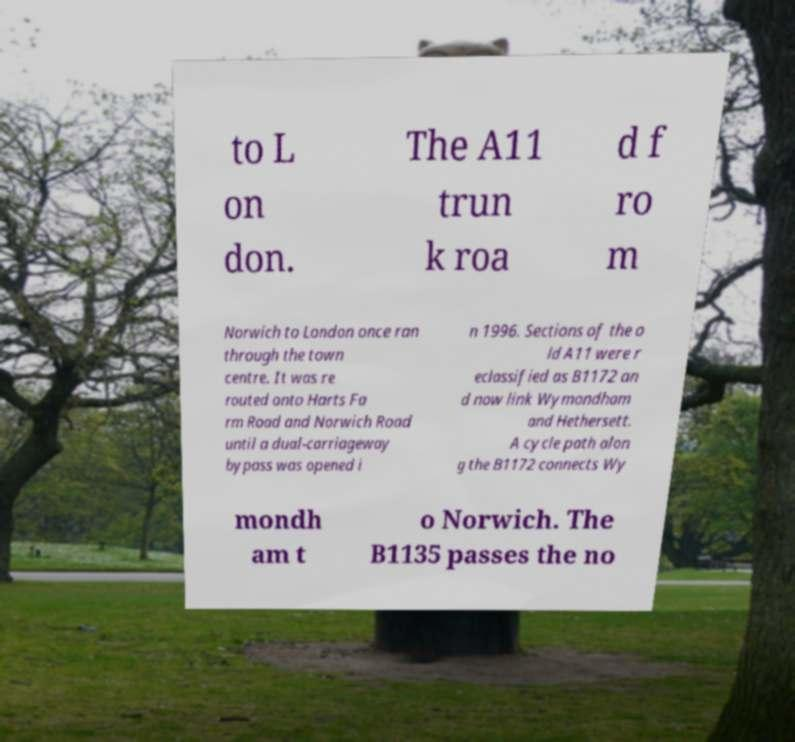Can you read and provide the text displayed in the image?This photo seems to have some interesting text. Can you extract and type it out for me? to L on don. The A11 trun k roa d f ro m Norwich to London once ran through the town centre. It was re routed onto Harts Fa rm Road and Norwich Road until a dual-carriageway bypass was opened i n 1996. Sections of the o ld A11 were r eclassified as B1172 an d now link Wymondham and Hethersett. A cycle path alon g the B1172 connects Wy mondh am t o Norwich. The B1135 passes the no 